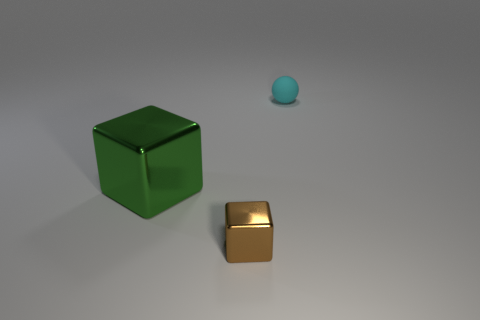What could be the purpose of showcasing these objects in such a minimalist environment? Presenting objects in a minimalist setting draws the viewer's attention to the objects themselves, allowing for a focused examination of their shapes, materials, and the interplay of light and shadow. It's a common technique in product visualization to highlight the item's design and features without distractions.  Could the lighting in the image be used to infer the time of day? The lighting in the image appears artificial, likely from a neutral light source rather than natural sunlight. Therefore, it doesn't provide clues about the time of day. The light seems designed to create soft shadows and enhance the object's dimensions and material qualities. 